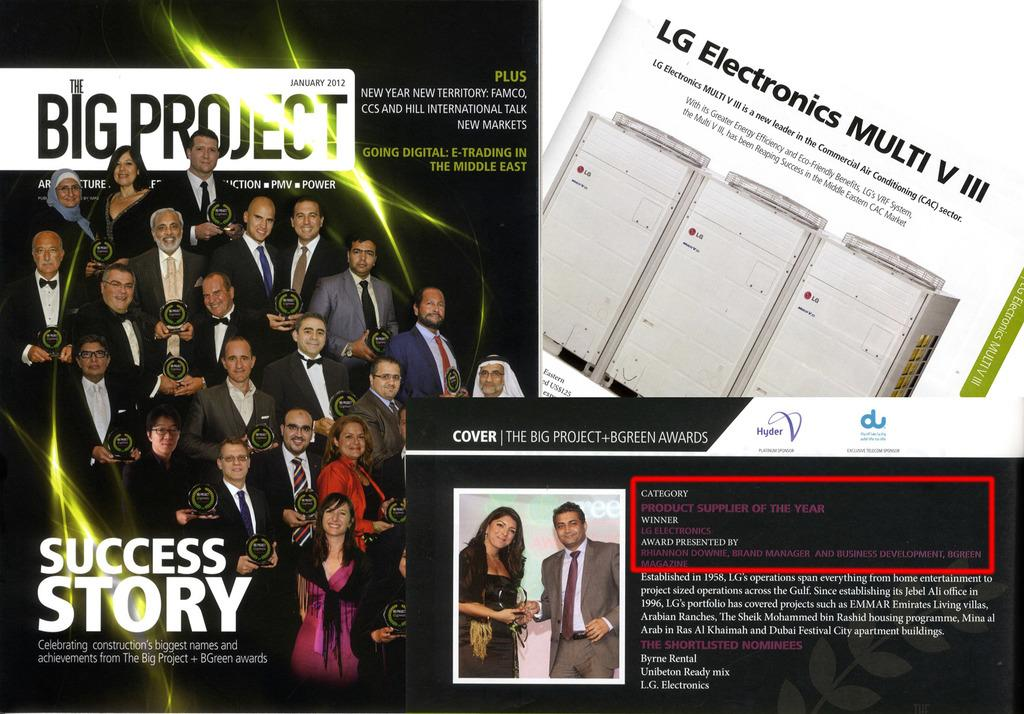<image>
Give a short and clear explanation of the subsequent image. A January 2012 Big Project magazine cover with about a dozen people. 